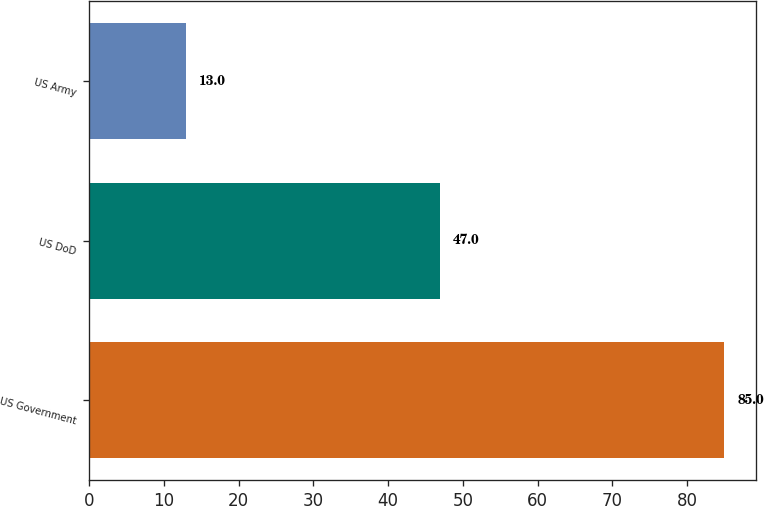<chart> <loc_0><loc_0><loc_500><loc_500><bar_chart><fcel>US Government<fcel>US DoD<fcel>US Army<nl><fcel>85<fcel>47<fcel>13<nl></chart> 